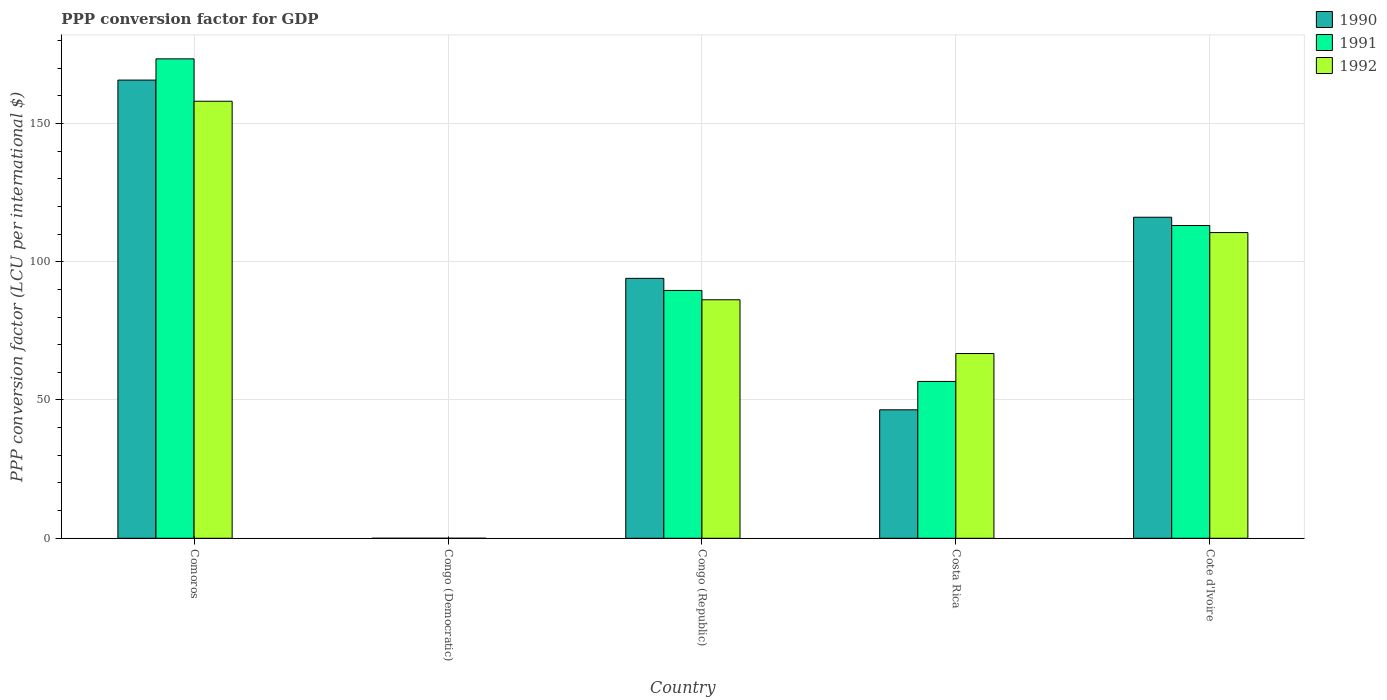How many groups of bars are there?
Your answer should be very brief. 5. Are the number of bars per tick equal to the number of legend labels?
Your answer should be compact. Yes. What is the label of the 5th group of bars from the left?
Your response must be concise. Cote d'Ivoire. In how many cases, is the number of bars for a given country not equal to the number of legend labels?
Provide a succinct answer. 0. What is the PPP conversion factor for GDP in 1992 in Congo (Democratic)?
Your answer should be compact. 7.132896045372209e-7. Across all countries, what is the maximum PPP conversion factor for GDP in 1990?
Keep it short and to the point. 165.66. Across all countries, what is the minimum PPP conversion factor for GDP in 1990?
Ensure brevity in your answer.  7.8159328794866e-10. In which country was the PPP conversion factor for GDP in 1990 maximum?
Your answer should be compact. Comoros. In which country was the PPP conversion factor for GDP in 1992 minimum?
Your answer should be compact. Congo (Democratic). What is the total PPP conversion factor for GDP in 1992 in the graph?
Make the answer very short. 421.58. What is the difference between the PPP conversion factor for GDP in 1990 in Congo (Democratic) and that in Cote d'Ivoire?
Give a very brief answer. -116.07. What is the difference between the PPP conversion factor for GDP in 1992 in Cote d'Ivoire and the PPP conversion factor for GDP in 1990 in Congo (Republic)?
Your response must be concise. 16.55. What is the average PPP conversion factor for GDP in 1992 per country?
Give a very brief answer. 84.32. What is the difference between the PPP conversion factor for GDP of/in 1992 and PPP conversion factor for GDP of/in 1991 in Congo (Democratic)?
Provide a short and direct response. 6.948447838540638e-7. In how many countries, is the PPP conversion factor for GDP in 1991 greater than 160 LCU?
Ensure brevity in your answer.  1. What is the ratio of the PPP conversion factor for GDP in 1992 in Congo (Republic) to that in Cote d'Ivoire?
Offer a terse response. 0.78. Is the PPP conversion factor for GDP in 1992 in Costa Rica less than that in Cote d'Ivoire?
Your response must be concise. Yes. Is the difference between the PPP conversion factor for GDP in 1992 in Congo (Democratic) and Cote d'Ivoire greater than the difference between the PPP conversion factor for GDP in 1991 in Congo (Democratic) and Cote d'Ivoire?
Provide a short and direct response. Yes. What is the difference between the highest and the second highest PPP conversion factor for GDP in 1991?
Your response must be concise. -23.47. What is the difference between the highest and the lowest PPP conversion factor for GDP in 1991?
Your response must be concise. 173.34. Is the sum of the PPP conversion factor for GDP in 1991 in Congo (Republic) and Cote d'Ivoire greater than the maximum PPP conversion factor for GDP in 1990 across all countries?
Offer a terse response. Yes. What does the 3rd bar from the left in Congo (Democratic) represents?
Provide a short and direct response. 1992. Is it the case that in every country, the sum of the PPP conversion factor for GDP in 1992 and PPP conversion factor for GDP in 1990 is greater than the PPP conversion factor for GDP in 1991?
Make the answer very short. Yes. How many bars are there?
Keep it short and to the point. 15. Are all the bars in the graph horizontal?
Provide a succinct answer. No. How many countries are there in the graph?
Provide a short and direct response. 5. Does the graph contain any zero values?
Offer a very short reply. No. What is the title of the graph?
Make the answer very short. PPP conversion factor for GDP. Does "1996" appear as one of the legend labels in the graph?
Make the answer very short. No. What is the label or title of the X-axis?
Ensure brevity in your answer.  Country. What is the label or title of the Y-axis?
Keep it short and to the point. PPP conversion factor (LCU per international $). What is the PPP conversion factor (LCU per international $) in 1990 in Comoros?
Provide a succinct answer. 165.66. What is the PPP conversion factor (LCU per international $) of 1991 in Comoros?
Provide a short and direct response. 173.34. What is the PPP conversion factor (LCU per international $) in 1992 in Comoros?
Ensure brevity in your answer.  158.01. What is the PPP conversion factor (LCU per international $) in 1990 in Congo (Democratic)?
Your response must be concise. 7.8159328794866e-10. What is the PPP conversion factor (LCU per international $) in 1991 in Congo (Democratic)?
Give a very brief answer. 1.84448206831571e-8. What is the PPP conversion factor (LCU per international $) in 1992 in Congo (Democratic)?
Ensure brevity in your answer.  7.132896045372209e-7. What is the PPP conversion factor (LCU per international $) of 1990 in Congo (Republic)?
Offer a very short reply. 93.98. What is the PPP conversion factor (LCU per international $) of 1991 in Congo (Republic)?
Make the answer very short. 89.6. What is the PPP conversion factor (LCU per international $) of 1992 in Congo (Republic)?
Give a very brief answer. 86.23. What is the PPP conversion factor (LCU per international $) in 1990 in Costa Rica?
Offer a terse response. 46.45. What is the PPP conversion factor (LCU per international $) of 1991 in Costa Rica?
Your answer should be very brief. 56.71. What is the PPP conversion factor (LCU per international $) of 1992 in Costa Rica?
Make the answer very short. 66.8. What is the PPP conversion factor (LCU per international $) in 1990 in Cote d'Ivoire?
Provide a succinct answer. 116.07. What is the PPP conversion factor (LCU per international $) of 1991 in Cote d'Ivoire?
Provide a succinct answer. 113.08. What is the PPP conversion factor (LCU per international $) of 1992 in Cote d'Ivoire?
Offer a very short reply. 110.53. Across all countries, what is the maximum PPP conversion factor (LCU per international $) of 1990?
Offer a terse response. 165.66. Across all countries, what is the maximum PPP conversion factor (LCU per international $) in 1991?
Give a very brief answer. 173.34. Across all countries, what is the maximum PPP conversion factor (LCU per international $) in 1992?
Offer a terse response. 158.01. Across all countries, what is the minimum PPP conversion factor (LCU per international $) of 1990?
Make the answer very short. 7.8159328794866e-10. Across all countries, what is the minimum PPP conversion factor (LCU per international $) in 1991?
Provide a short and direct response. 1.84448206831571e-8. Across all countries, what is the minimum PPP conversion factor (LCU per international $) in 1992?
Keep it short and to the point. 7.132896045372209e-7. What is the total PPP conversion factor (LCU per international $) in 1990 in the graph?
Make the answer very short. 422.16. What is the total PPP conversion factor (LCU per international $) of 1991 in the graph?
Give a very brief answer. 432.73. What is the total PPP conversion factor (LCU per international $) of 1992 in the graph?
Make the answer very short. 421.58. What is the difference between the PPP conversion factor (LCU per international $) in 1990 in Comoros and that in Congo (Democratic)?
Your answer should be very brief. 165.66. What is the difference between the PPP conversion factor (LCU per international $) in 1991 in Comoros and that in Congo (Democratic)?
Ensure brevity in your answer.  173.34. What is the difference between the PPP conversion factor (LCU per international $) in 1992 in Comoros and that in Congo (Democratic)?
Ensure brevity in your answer.  158.01. What is the difference between the PPP conversion factor (LCU per international $) in 1990 in Comoros and that in Congo (Republic)?
Offer a terse response. 71.68. What is the difference between the PPP conversion factor (LCU per international $) in 1991 in Comoros and that in Congo (Republic)?
Offer a terse response. 83.74. What is the difference between the PPP conversion factor (LCU per international $) in 1992 in Comoros and that in Congo (Republic)?
Offer a terse response. 71.78. What is the difference between the PPP conversion factor (LCU per international $) of 1990 in Comoros and that in Costa Rica?
Offer a very short reply. 119.21. What is the difference between the PPP conversion factor (LCU per international $) in 1991 in Comoros and that in Costa Rica?
Offer a very short reply. 116.63. What is the difference between the PPP conversion factor (LCU per international $) of 1992 in Comoros and that in Costa Rica?
Give a very brief answer. 91.21. What is the difference between the PPP conversion factor (LCU per international $) in 1990 in Comoros and that in Cote d'Ivoire?
Give a very brief answer. 49.59. What is the difference between the PPP conversion factor (LCU per international $) of 1991 in Comoros and that in Cote d'Ivoire?
Provide a succinct answer. 60.26. What is the difference between the PPP conversion factor (LCU per international $) in 1992 in Comoros and that in Cote d'Ivoire?
Provide a succinct answer. 47.48. What is the difference between the PPP conversion factor (LCU per international $) of 1990 in Congo (Democratic) and that in Congo (Republic)?
Offer a very short reply. -93.98. What is the difference between the PPP conversion factor (LCU per international $) in 1991 in Congo (Democratic) and that in Congo (Republic)?
Make the answer very short. -89.6. What is the difference between the PPP conversion factor (LCU per international $) in 1992 in Congo (Democratic) and that in Congo (Republic)?
Offer a very short reply. -86.23. What is the difference between the PPP conversion factor (LCU per international $) in 1990 in Congo (Democratic) and that in Costa Rica?
Offer a very short reply. -46.45. What is the difference between the PPP conversion factor (LCU per international $) of 1991 in Congo (Democratic) and that in Costa Rica?
Provide a short and direct response. -56.71. What is the difference between the PPP conversion factor (LCU per international $) in 1992 in Congo (Democratic) and that in Costa Rica?
Make the answer very short. -66.8. What is the difference between the PPP conversion factor (LCU per international $) in 1990 in Congo (Democratic) and that in Cote d'Ivoire?
Give a very brief answer. -116.07. What is the difference between the PPP conversion factor (LCU per international $) in 1991 in Congo (Democratic) and that in Cote d'Ivoire?
Your answer should be very brief. -113.08. What is the difference between the PPP conversion factor (LCU per international $) in 1992 in Congo (Democratic) and that in Cote d'Ivoire?
Your answer should be compact. -110.53. What is the difference between the PPP conversion factor (LCU per international $) of 1990 in Congo (Republic) and that in Costa Rica?
Offer a very short reply. 47.53. What is the difference between the PPP conversion factor (LCU per international $) in 1991 in Congo (Republic) and that in Costa Rica?
Provide a succinct answer. 32.9. What is the difference between the PPP conversion factor (LCU per international $) in 1992 in Congo (Republic) and that in Costa Rica?
Ensure brevity in your answer.  19.43. What is the difference between the PPP conversion factor (LCU per international $) in 1990 in Congo (Republic) and that in Cote d'Ivoire?
Your answer should be compact. -22.09. What is the difference between the PPP conversion factor (LCU per international $) in 1991 in Congo (Republic) and that in Cote d'Ivoire?
Your answer should be compact. -23.47. What is the difference between the PPP conversion factor (LCU per international $) of 1992 in Congo (Republic) and that in Cote d'Ivoire?
Offer a terse response. -24.3. What is the difference between the PPP conversion factor (LCU per international $) in 1990 in Costa Rica and that in Cote d'Ivoire?
Give a very brief answer. -69.62. What is the difference between the PPP conversion factor (LCU per international $) of 1991 in Costa Rica and that in Cote d'Ivoire?
Your response must be concise. -56.37. What is the difference between the PPP conversion factor (LCU per international $) in 1992 in Costa Rica and that in Cote d'Ivoire?
Provide a succinct answer. -43.73. What is the difference between the PPP conversion factor (LCU per international $) in 1990 in Comoros and the PPP conversion factor (LCU per international $) in 1991 in Congo (Democratic)?
Your response must be concise. 165.66. What is the difference between the PPP conversion factor (LCU per international $) of 1990 in Comoros and the PPP conversion factor (LCU per international $) of 1992 in Congo (Democratic)?
Ensure brevity in your answer.  165.66. What is the difference between the PPP conversion factor (LCU per international $) in 1991 in Comoros and the PPP conversion factor (LCU per international $) in 1992 in Congo (Democratic)?
Your answer should be compact. 173.34. What is the difference between the PPP conversion factor (LCU per international $) in 1990 in Comoros and the PPP conversion factor (LCU per international $) in 1991 in Congo (Republic)?
Offer a very short reply. 76.06. What is the difference between the PPP conversion factor (LCU per international $) in 1990 in Comoros and the PPP conversion factor (LCU per international $) in 1992 in Congo (Republic)?
Make the answer very short. 79.43. What is the difference between the PPP conversion factor (LCU per international $) in 1991 in Comoros and the PPP conversion factor (LCU per international $) in 1992 in Congo (Republic)?
Offer a very short reply. 87.11. What is the difference between the PPP conversion factor (LCU per international $) of 1990 in Comoros and the PPP conversion factor (LCU per international $) of 1991 in Costa Rica?
Provide a succinct answer. 108.95. What is the difference between the PPP conversion factor (LCU per international $) of 1990 in Comoros and the PPP conversion factor (LCU per international $) of 1992 in Costa Rica?
Your answer should be very brief. 98.86. What is the difference between the PPP conversion factor (LCU per international $) in 1991 in Comoros and the PPP conversion factor (LCU per international $) in 1992 in Costa Rica?
Your answer should be very brief. 106.54. What is the difference between the PPP conversion factor (LCU per international $) of 1990 in Comoros and the PPP conversion factor (LCU per international $) of 1991 in Cote d'Ivoire?
Provide a short and direct response. 52.58. What is the difference between the PPP conversion factor (LCU per international $) of 1990 in Comoros and the PPP conversion factor (LCU per international $) of 1992 in Cote d'Ivoire?
Offer a very short reply. 55.13. What is the difference between the PPP conversion factor (LCU per international $) in 1991 in Comoros and the PPP conversion factor (LCU per international $) in 1992 in Cote d'Ivoire?
Keep it short and to the point. 62.81. What is the difference between the PPP conversion factor (LCU per international $) of 1990 in Congo (Democratic) and the PPP conversion factor (LCU per international $) of 1991 in Congo (Republic)?
Give a very brief answer. -89.6. What is the difference between the PPP conversion factor (LCU per international $) in 1990 in Congo (Democratic) and the PPP conversion factor (LCU per international $) in 1992 in Congo (Republic)?
Ensure brevity in your answer.  -86.23. What is the difference between the PPP conversion factor (LCU per international $) in 1991 in Congo (Democratic) and the PPP conversion factor (LCU per international $) in 1992 in Congo (Republic)?
Your answer should be very brief. -86.23. What is the difference between the PPP conversion factor (LCU per international $) of 1990 in Congo (Democratic) and the PPP conversion factor (LCU per international $) of 1991 in Costa Rica?
Your answer should be compact. -56.71. What is the difference between the PPP conversion factor (LCU per international $) of 1990 in Congo (Democratic) and the PPP conversion factor (LCU per international $) of 1992 in Costa Rica?
Make the answer very short. -66.8. What is the difference between the PPP conversion factor (LCU per international $) of 1991 in Congo (Democratic) and the PPP conversion factor (LCU per international $) of 1992 in Costa Rica?
Give a very brief answer. -66.8. What is the difference between the PPP conversion factor (LCU per international $) of 1990 in Congo (Democratic) and the PPP conversion factor (LCU per international $) of 1991 in Cote d'Ivoire?
Offer a very short reply. -113.08. What is the difference between the PPP conversion factor (LCU per international $) in 1990 in Congo (Democratic) and the PPP conversion factor (LCU per international $) in 1992 in Cote d'Ivoire?
Your response must be concise. -110.53. What is the difference between the PPP conversion factor (LCU per international $) of 1991 in Congo (Democratic) and the PPP conversion factor (LCU per international $) of 1992 in Cote d'Ivoire?
Ensure brevity in your answer.  -110.53. What is the difference between the PPP conversion factor (LCU per international $) in 1990 in Congo (Republic) and the PPP conversion factor (LCU per international $) in 1991 in Costa Rica?
Your answer should be compact. 37.27. What is the difference between the PPP conversion factor (LCU per international $) in 1990 in Congo (Republic) and the PPP conversion factor (LCU per international $) in 1992 in Costa Rica?
Ensure brevity in your answer.  27.18. What is the difference between the PPP conversion factor (LCU per international $) in 1991 in Congo (Republic) and the PPP conversion factor (LCU per international $) in 1992 in Costa Rica?
Ensure brevity in your answer.  22.8. What is the difference between the PPP conversion factor (LCU per international $) of 1990 in Congo (Republic) and the PPP conversion factor (LCU per international $) of 1991 in Cote d'Ivoire?
Provide a succinct answer. -19.1. What is the difference between the PPP conversion factor (LCU per international $) of 1990 in Congo (Republic) and the PPP conversion factor (LCU per international $) of 1992 in Cote d'Ivoire?
Offer a very short reply. -16.55. What is the difference between the PPP conversion factor (LCU per international $) of 1991 in Congo (Republic) and the PPP conversion factor (LCU per international $) of 1992 in Cote d'Ivoire?
Offer a terse response. -20.93. What is the difference between the PPP conversion factor (LCU per international $) in 1990 in Costa Rica and the PPP conversion factor (LCU per international $) in 1991 in Cote d'Ivoire?
Provide a succinct answer. -66.63. What is the difference between the PPP conversion factor (LCU per international $) of 1990 in Costa Rica and the PPP conversion factor (LCU per international $) of 1992 in Cote d'Ivoire?
Your response must be concise. -64.08. What is the difference between the PPP conversion factor (LCU per international $) in 1991 in Costa Rica and the PPP conversion factor (LCU per international $) in 1992 in Cote d'Ivoire?
Ensure brevity in your answer.  -53.82. What is the average PPP conversion factor (LCU per international $) in 1990 per country?
Your response must be concise. 84.43. What is the average PPP conversion factor (LCU per international $) in 1991 per country?
Keep it short and to the point. 86.55. What is the average PPP conversion factor (LCU per international $) in 1992 per country?
Your response must be concise. 84.32. What is the difference between the PPP conversion factor (LCU per international $) of 1990 and PPP conversion factor (LCU per international $) of 1991 in Comoros?
Provide a succinct answer. -7.68. What is the difference between the PPP conversion factor (LCU per international $) of 1990 and PPP conversion factor (LCU per international $) of 1992 in Comoros?
Offer a terse response. 7.65. What is the difference between the PPP conversion factor (LCU per international $) of 1991 and PPP conversion factor (LCU per international $) of 1992 in Comoros?
Your answer should be very brief. 15.33. What is the difference between the PPP conversion factor (LCU per international $) in 1991 and PPP conversion factor (LCU per international $) in 1992 in Congo (Democratic)?
Your response must be concise. -0. What is the difference between the PPP conversion factor (LCU per international $) in 1990 and PPP conversion factor (LCU per international $) in 1991 in Congo (Republic)?
Give a very brief answer. 4.37. What is the difference between the PPP conversion factor (LCU per international $) in 1990 and PPP conversion factor (LCU per international $) in 1992 in Congo (Republic)?
Your answer should be very brief. 7.75. What is the difference between the PPP conversion factor (LCU per international $) in 1991 and PPP conversion factor (LCU per international $) in 1992 in Congo (Republic)?
Give a very brief answer. 3.37. What is the difference between the PPP conversion factor (LCU per international $) of 1990 and PPP conversion factor (LCU per international $) of 1991 in Costa Rica?
Your response must be concise. -10.26. What is the difference between the PPP conversion factor (LCU per international $) in 1990 and PPP conversion factor (LCU per international $) in 1992 in Costa Rica?
Offer a terse response. -20.35. What is the difference between the PPP conversion factor (LCU per international $) in 1991 and PPP conversion factor (LCU per international $) in 1992 in Costa Rica?
Provide a succinct answer. -10.09. What is the difference between the PPP conversion factor (LCU per international $) of 1990 and PPP conversion factor (LCU per international $) of 1991 in Cote d'Ivoire?
Your answer should be compact. 2.99. What is the difference between the PPP conversion factor (LCU per international $) of 1990 and PPP conversion factor (LCU per international $) of 1992 in Cote d'Ivoire?
Your response must be concise. 5.54. What is the difference between the PPP conversion factor (LCU per international $) of 1991 and PPP conversion factor (LCU per international $) of 1992 in Cote d'Ivoire?
Keep it short and to the point. 2.55. What is the ratio of the PPP conversion factor (LCU per international $) of 1990 in Comoros to that in Congo (Democratic)?
Give a very brief answer. 2.12e+11. What is the ratio of the PPP conversion factor (LCU per international $) of 1991 in Comoros to that in Congo (Democratic)?
Your response must be concise. 9.40e+09. What is the ratio of the PPP conversion factor (LCU per international $) of 1992 in Comoros to that in Congo (Democratic)?
Provide a short and direct response. 2.22e+08. What is the ratio of the PPP conversion factor (LCU per international $) of 1990 in Comoros to that in Congo (Republic)?
Give a very brief answer. 1.76. What is the ratio of the PPP conversion factor (LCU per international $) in 1991 in Comoros to that in Congo (Republic)?
Your response must be concise. 1.93. What is the ratio of the PPP conversion factor (LCU per international $) of 1992 in Comoros to that in Congo (Republic)?
Provide a short and direct response. 1.83. What is the ratio of the PPP conversion factor (LCU per international $) of 1990 in Comoros to that in Costa Rica?
Keep it short and to the point. 3.57. What is the ratio of the PPP conversion factor (LCU per international $) in 1991 in Comoros to that in Costa Rica?
Your response must be concise. 3.06. What is the ratio of the PPP conversion factor (LCU per international $) of 1992 in Comoros to that in Costa Rica?
Offer a terse response. 2.37. What is the ratio of the PPP conversion factor (LCU per international $) in 1990 in Comoros to that in Cote d'Ivoire?
Provide a succinct answer. 1.43. What is the ratio of the PPP conversion factor (LCU per international $) of 1991 in Comoros to that in Cote d'Ivoire?
Offer a very short reply. 1.53. What is the ratio of the PPP conversion factor (LCU per international $) in 1992 in Comoros to that in Cote d'Ivoire?
Make the answer very short. 1.43. What is the ratio of the PPP conversion factor (LCU per international $) of 1990 in Congo (Democratic) to that in Congo (Republic)?
Your answer should be very brief. 0. What is the ratio of the PPP conversion factor (LCU per international $) in 1991 in Congo (Democratic) to that in Congo (Republic)?
Give a very brief answer. 0. What is the ratio of the PPP conversion factor (LCU per international $) in 1991 in Congo (Democratic) to that in Costa Rica?
Ensure brevity in your answer.  0. What is the ratio of the PPP conversion factor (LCU per international $) of 1992 in Congo (Democratic) to that in Costa Rica?
Keep it short and to the point. 0. What is the ratio of the PPP conversion factor (LCU per international $) of 1991 in Congo (Democratic) to that in Cote d'Ivoire?
Your answer should be compact. 0. What is the ratio of the PPP conversion factor (LCU per international $) in 1990 in Congo (Republic) to that in Costa Rica?
Keep it short and to the point. 2.02. What is the ratio of the PPP conversion factor (LCU per international $) of 1991 in Congo (Republic) to that in Costa Rica?
Give a very brief answer. 1.58. What is the ratio of the PPP conversion factor (LCU per international $) in 1992 in Congo (Republic) to that in Costa Rica?
Provide a short and direct response. 1.29. What is the ratio of the PPP conversion factor (LCU per international $) in 1990 in Congo (Republic) to that in Cote d'Ivoire?
Offer a very short reply. 0.81. What is the ratio of the PPP conversion factor (LCU per international $) of 1991 in Congo (Republic) to that in Cote d'Ivoire?
Keep it short and to the point. 0.79. What is the ratio of the PPP conversion factor (LCU per international $) of 1992 in Congo (Republic) to that in Cote d'Ivoire?
Offer a terse response. 0.78. What is the ratio of the PPP conversion factor (LCU per international $) of 1990 in Costa Rica to that in Cote d'Ivoire?
Your response must be concise. 0.4. What is the ratio of the PPP conversion factor (LCU per international $) of 1991 in Costa Rica to that in Cote d'Ivoire?
Provide a succinct answer. 0.5. What is the ratio of the PPP conversion factor (LCU per international $) in 1992 in Costa Rica to that in Cote d'Ivoire?
Offer a terse response. 0.6. What is the difference between the highest and the second highest PPP conversion factor (LCU per international $) in 1990?
Keep it short and to the point. 49.59. What is the difference between the highest and the second highest PPP conversion factor (LCU per international $) in 1991?
Provide a succinct answer. 60.26. What is the difference between the highest and the second highest PPP conversion factor (LCU per international $) of 1992?
Your answer should be very brief. 47.48. What is the difference between the highest and the lowest PPP conversion factor (LCU per international $) in 1990?
Give a very brief answer. 165.66. What is the difference between the highest and the lowest PPP conversion factor (LCU per international $) in 1991?
Your response must be concise. 173.34. What is the difference between the highest and the lowest PPP conversion factor (LCU per international $) in 1992?
Your answer should be compact. 158.01. 